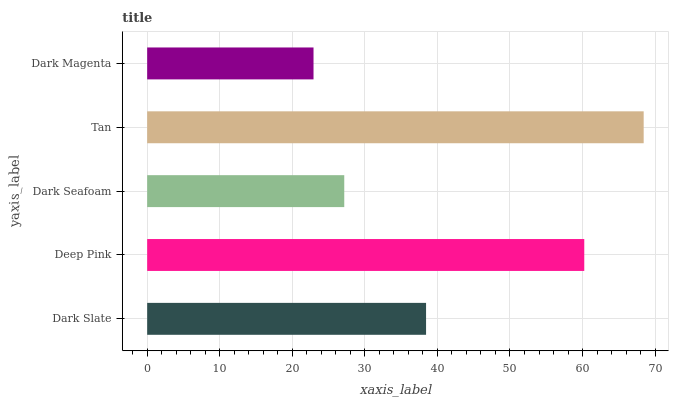Is Dark Magenta the minimum?
Answer yes or no. Yes. Is Tan the maximum?
Answer yes or no. Yes. Is Deep Pink the minimum?
Answer yes or no. No. Is Deep Pink the maximum?
Answer yes or no. No. Is Deep Pink greater than Dark Slate?
Answer yes or no. Yes. Is Dark Slate less than Deep Pink?
Answer yes or no. Yes. Is Dark Slate greater than Deep Pink?
Answer yes or no. No. Is Deep Pink less than Dark Slate?
Answer yes or no. No. Is Dark Slate the high median?
Answer yes or no. Yes. Is Dark Slate the low median?
Answer yes or no. Yes. Is Dark Magenta the high median?
Answer yes or no. No. Is Tan the low median?
Answer yes or no. No. 